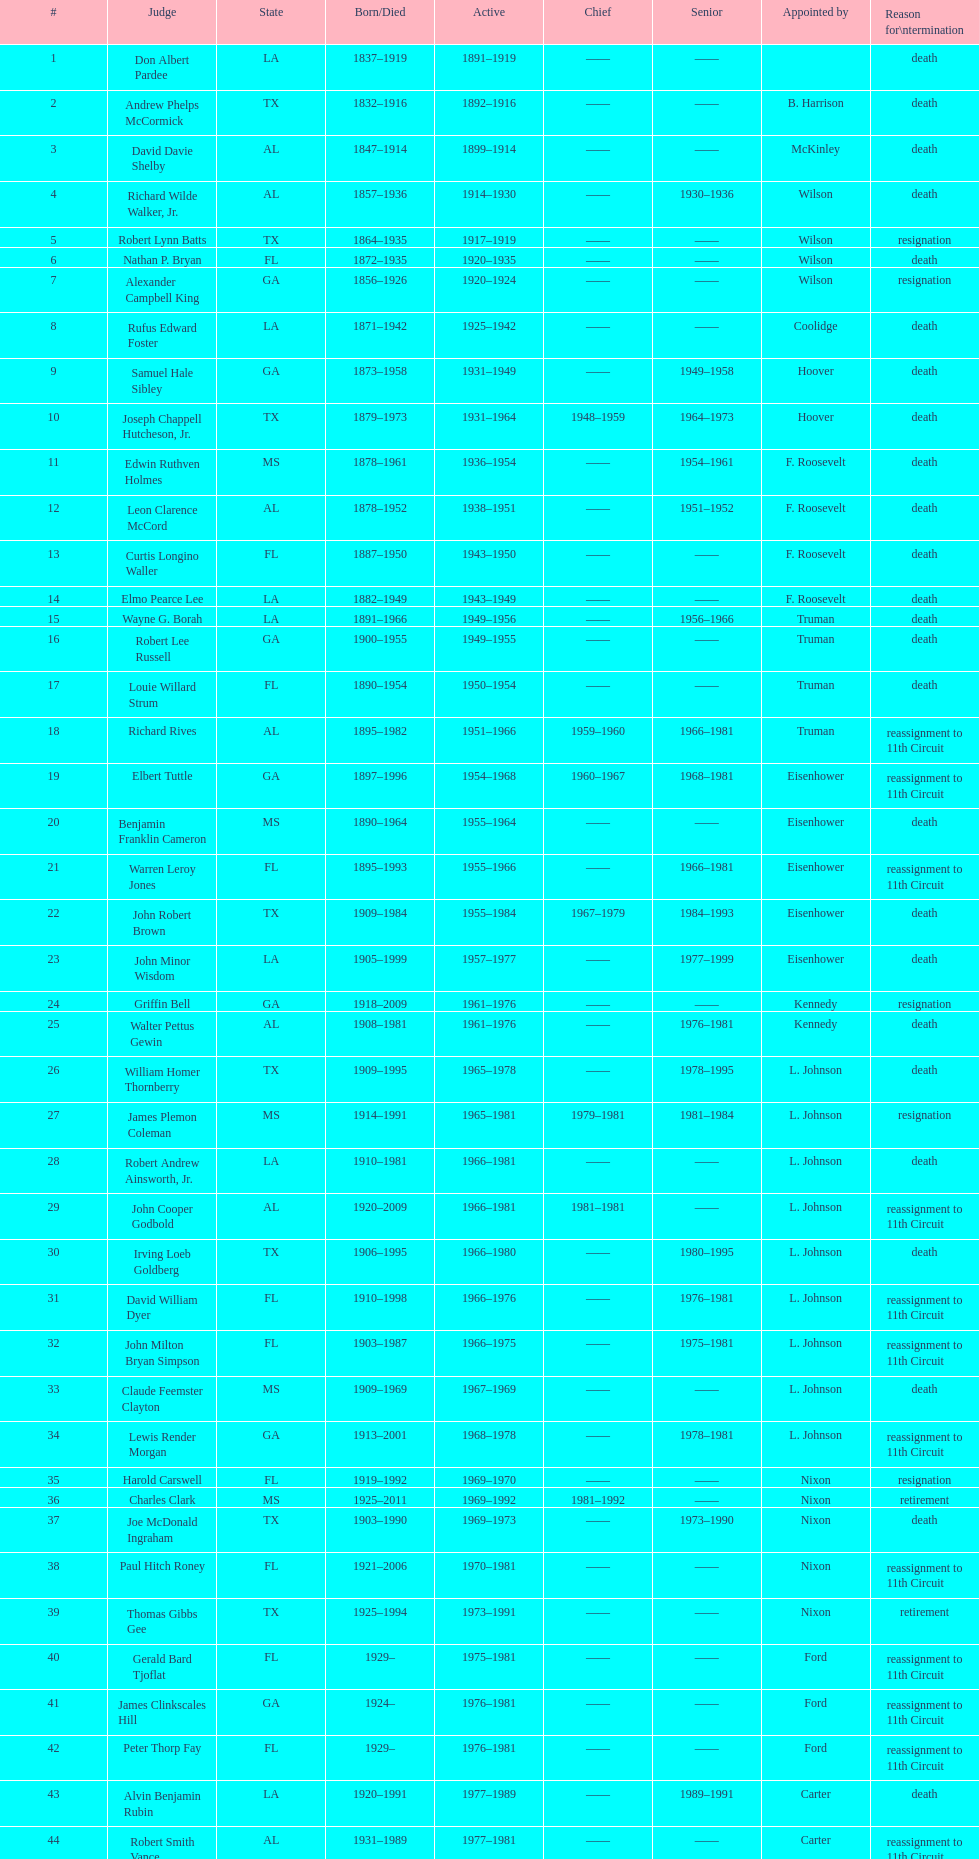In which state are the highest number of judges employed? TX. 